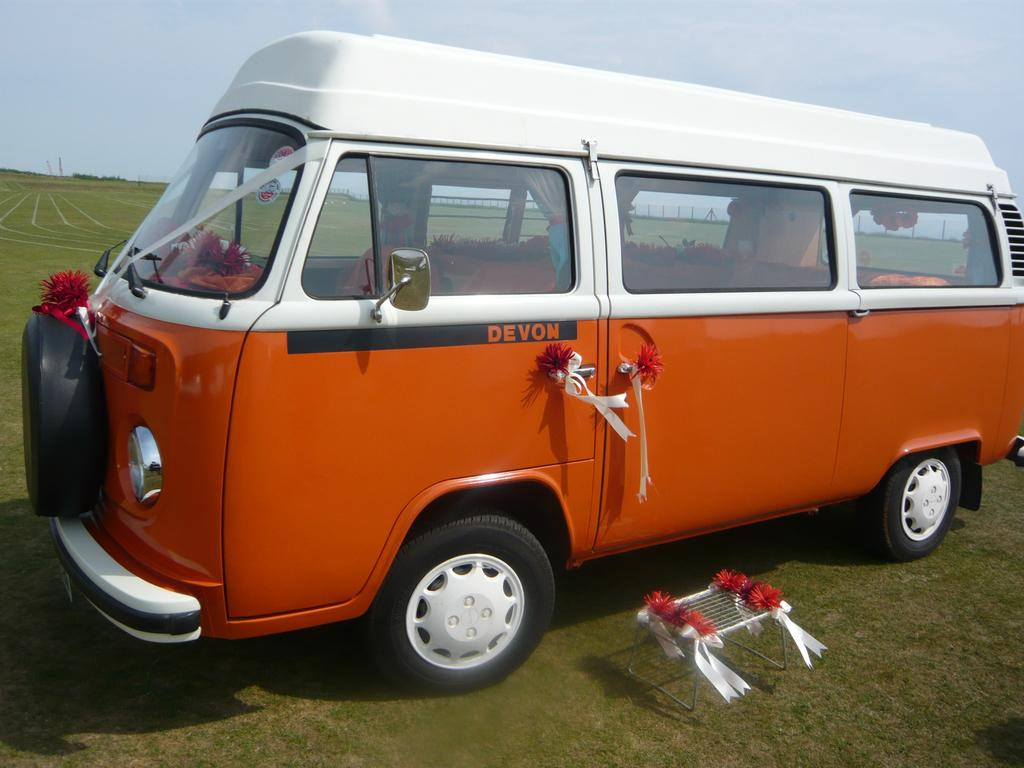<image>
Share a concise interpretation of the image provided. a DEVON orange and white mini bus parked on a grass field 